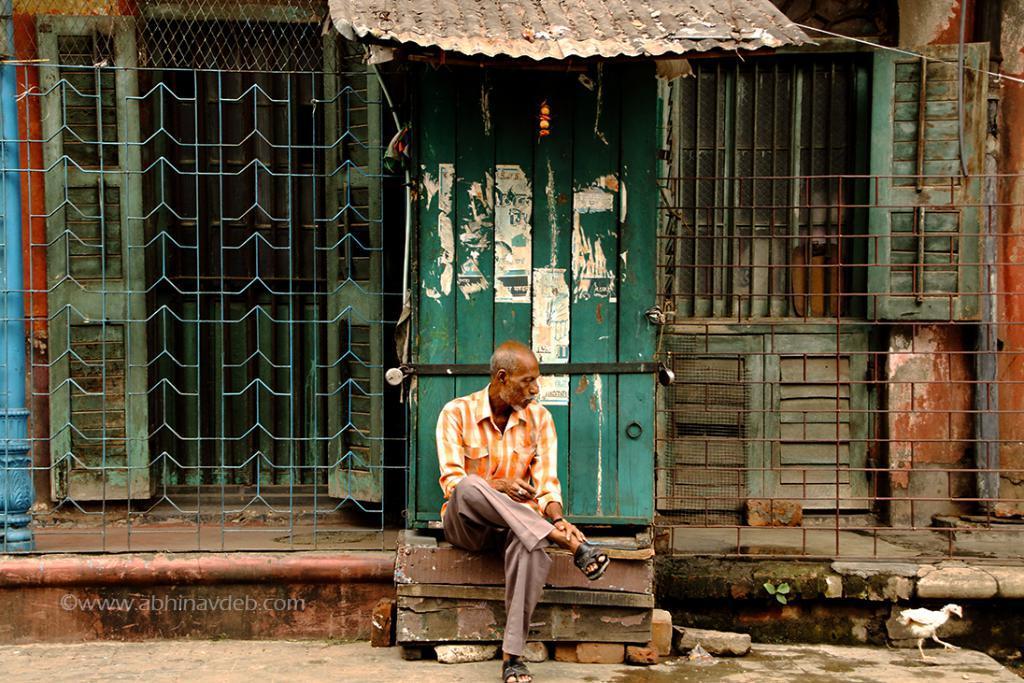Could you give a brief overview of what you see in this image? In this image we can see a house with roof and doors. We can see a person in front of the door. On the right side we can see a hen. 